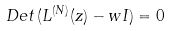Convert formula to latex. <formula><loc_0><loc_0><loc_500><loc_500>D e t \, ( L ^ { ( N ) } ( z ) - w I ) = 0</formula> 